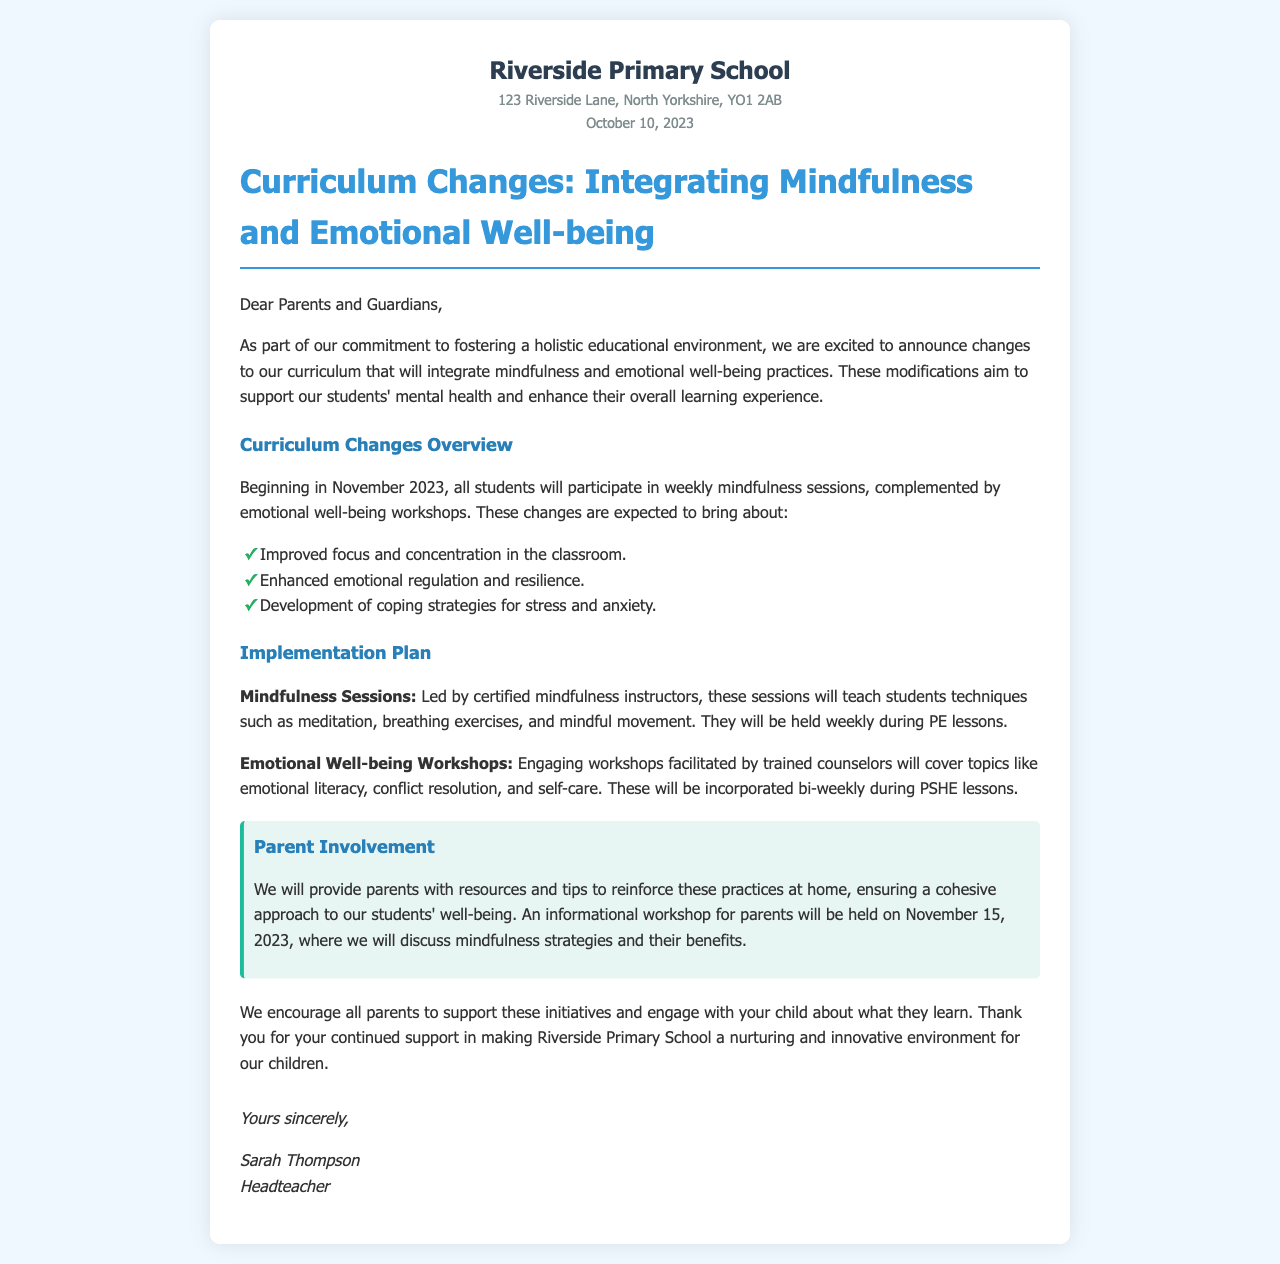what is the name of the school? The name of the school is mentioned in the header of the document.
Answer: Riverside Primary School when will the curriculum changes begin? The date when the curriculum changes will start is specified in the document.
Answer: November 2023 what type of sessions will students participate in? The document specifies two types of sessions that students will participate in.
Answer: mindfulness sessions who will lead the mindfulness sessions? The document provides information about who will be leading the mindfulness sessions.
Answer: certified mindfulness instructors what is the date of the informational workshop for parents? The date for the parent workshop is mentioned in the section regarding parent involvement.
Answer: November 15, 2023 what is the main aim of integrating mindfulness in the curriculum? The aim is detailed in the introduction of the document.
Answer: support students' mental health how often will emotional well-being workshops be held? The document indicates the frequency of the workshops in relation to the PSHE lessons.
Answer: bi-weekly what kind of topics will be covered in the workshops? The document lists the types of topics included in the workshops.
Answer: emotional literacy who signed the letter? The letter concludes with the signatory's name.
Answer: Sarah Thompson 